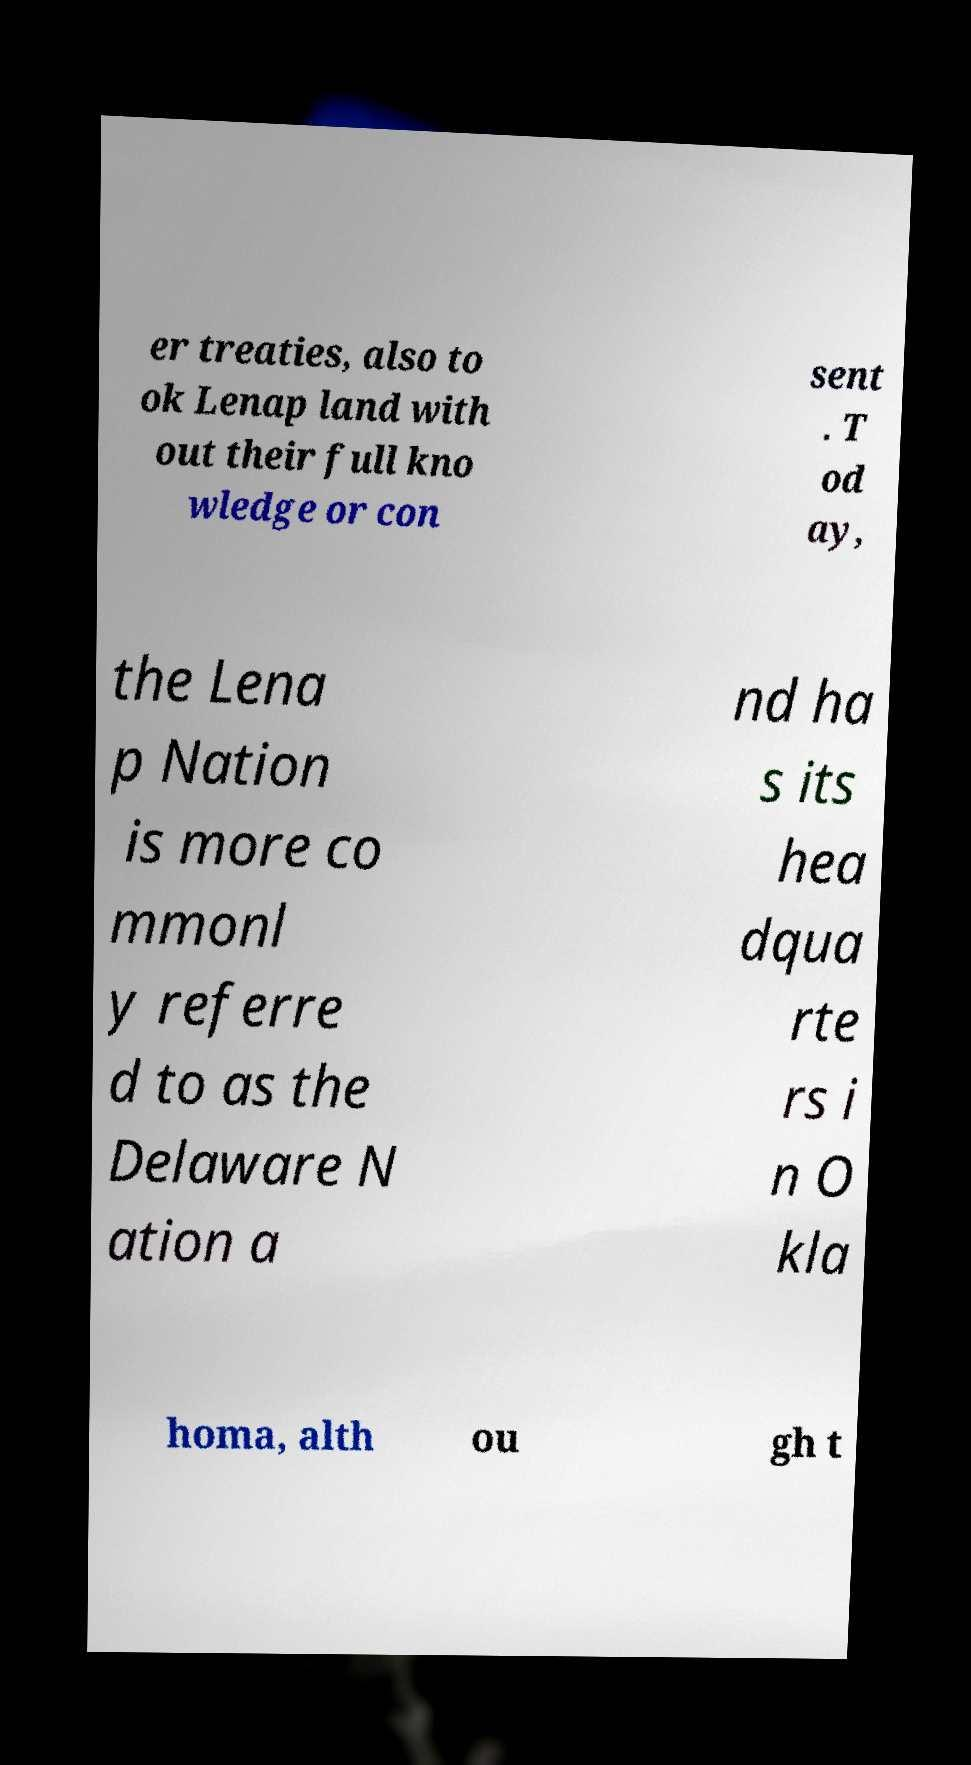Can you accurately transcribe the text from the provided image for me? er treaties, also to ok Lenap land with out their full kno wledge or con sent . T od ay, the Lena p Nation is more co mmonl y referre d to as the Delaware N ation a nd ha s its hea dqua rte rs i n O kla homa, alth ou gh t 